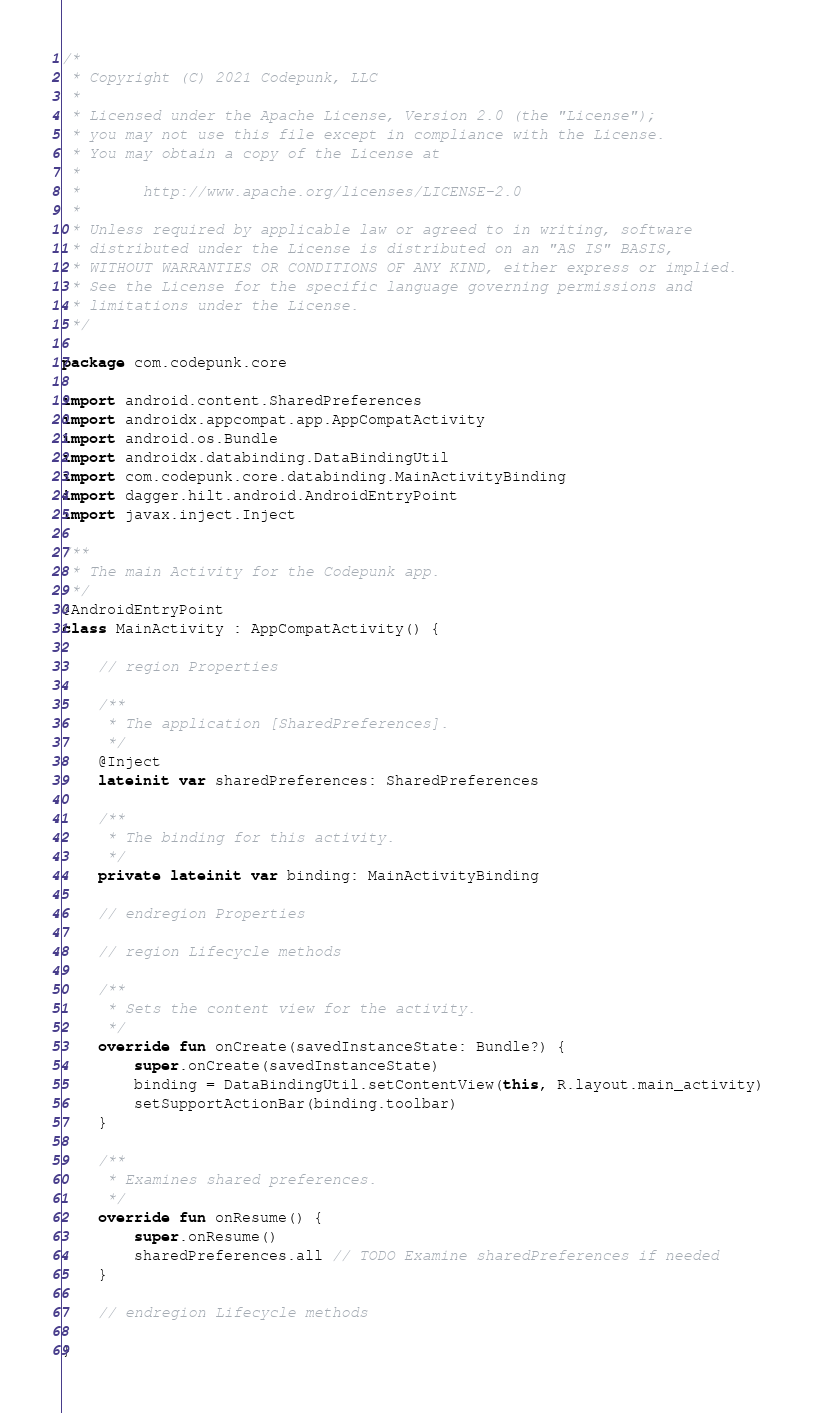Convert code to text. <code><loc_0><loc_0><loc_500><loc_500><_Kotlin_>/*
 * Copyright (C) 2021 Codepunk, LLC
 *
 * Licensed under the Apache License, Version 2.0 (the "License");
 * you may not use this file except in compliance with the License.
 * You may obtain a copy of the License at
 *
 *       http://www.apache.org/licenses/LICENSE-2.0
 *
 * Unless required by applicable law or agreed to in writing, software
 * distributed under the License is distributed on an "AS IS" BASIS,
 * WITHOUT WARRANTIES OR CONDITIONS OF ANY KIND, either express or implied.
 * See the License for the specific language governing permissions and
 * limitations under the License.
 */

package com.codepunk.core

import android.content.SharedPreferences
import androidx.appcompat.app.AppCompatActivity
import android.os.Bundle
import androidx.databinding.DataBindingUtil
import com.codepunk.core.databinding.MainActivityBinding
import dagger.hilt.android.AndroidEntryPoint
import javax.inject.Inject

/**
 * The main Activity for the Codepunk app.
 */
@AndroidEntryPoint
class MainActivity : AppCompatActivity() {

    // region Properties

    /**
     * The application [SharedPreferences].
     */
    @Inject
    lateinit var sharedPreferences: SharedPreferences

    /**
     * The binding for this activity.
     */
    private lateinit var binding: MainActivityBinding

    // endregion Properties

    // region Lifecycle methods

    /**
     * Sets the content view for the activity.
     */
    override fun onCreate(savedInstanceState: Bundle?) {
        super.onCreate(savedInstanceState)
        binding = DataBindingUtil.setContentView(this, R.layout.main_activity)
        setSupportActionBar(binding.toolbar)
    }

    /**
     * Examines shared preferences.
     */
    override fun onResume() {
        super.onResume()
        sharedPreferences.all // TODO Examine sharedPreferences if needed
    }

    // endregion Lifecycle methods

}
</code> 